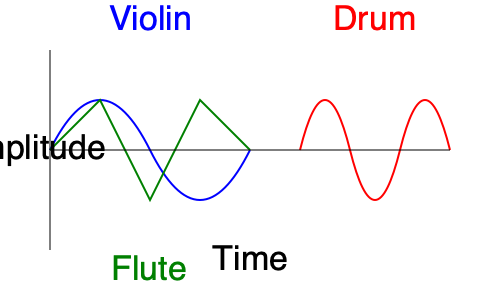Analyze the waveforms shown in the image for violin, flute, and drum. Which instrument's waveform exhibits the most complex harmonic structure, and how does this relate to its timbre? Explain your reasoning based on the visual representation and your understanding of sound wave characteristics. To answer this question, we need to analyze each instrument's waveform and understand how it relates to harmonic structure and timbre:

1. Violin waveform:
   - Shows a smooth, curved pattern with rounded peaks and troughs.
   - This indicates a rich harmonic content with a gradual blend of overtones.
   - The smoothness suggests a warm, complex timbre with many harmonics present.

2. Flute waveform:
   - Displays a more angular, triangular pattern.
   - This shape indicates fewer prominent harmonics compared to the violin.
   - The simpler waveform corresponds to a purer, more fundamental-dominated sound.

3. Drum waveform:
   - Exhibits a rapid initial spike followed by irregular, decreasing oscillations.
   - This pattern is characteristic of percussive instruments with a complex, noisy spectrum.
   - The quick attack and decay suggest a broad range of frequencies without clear harmonic relationships.

Harmonic structure relates to the presence and strength of overtones in a sound. More complex harmonic structures typically result in richer, more distinctive timbres.

The violin waveform shows the most complex harmonic structure among the three instruments. This is evident from:
1. The smooth, rounded shape indicating many harmonics blending together.
2. The consistent, repeating pattern suggesting a stable set of overtones.
3. The lack of sharp angles or simple geometric shapes, which would indicate fewer harmonics.

This complex waveform corresponds to the violin's rich, warm timbre that is often described as having depth and character. The numerous harmonics present in a violin's sound contribute to its ability to produce a wide range of tonal colors and expressiveness.

In contrast, the flute's simpler waveform indicates fewer prominent harmonics, resulting in a purer, more fundamental-dominated timbre. The drum's irregular waveform suggests a complex but less harmonic-based timbre, characterized more by its percussive qualities and broad frequency content rather than a clear harmonic series.
Answer: Violin; its smooth, curved waveform indicates the most complex harmonic structure, corresponding to a rich, warm timbre with numerous blended overtones. 